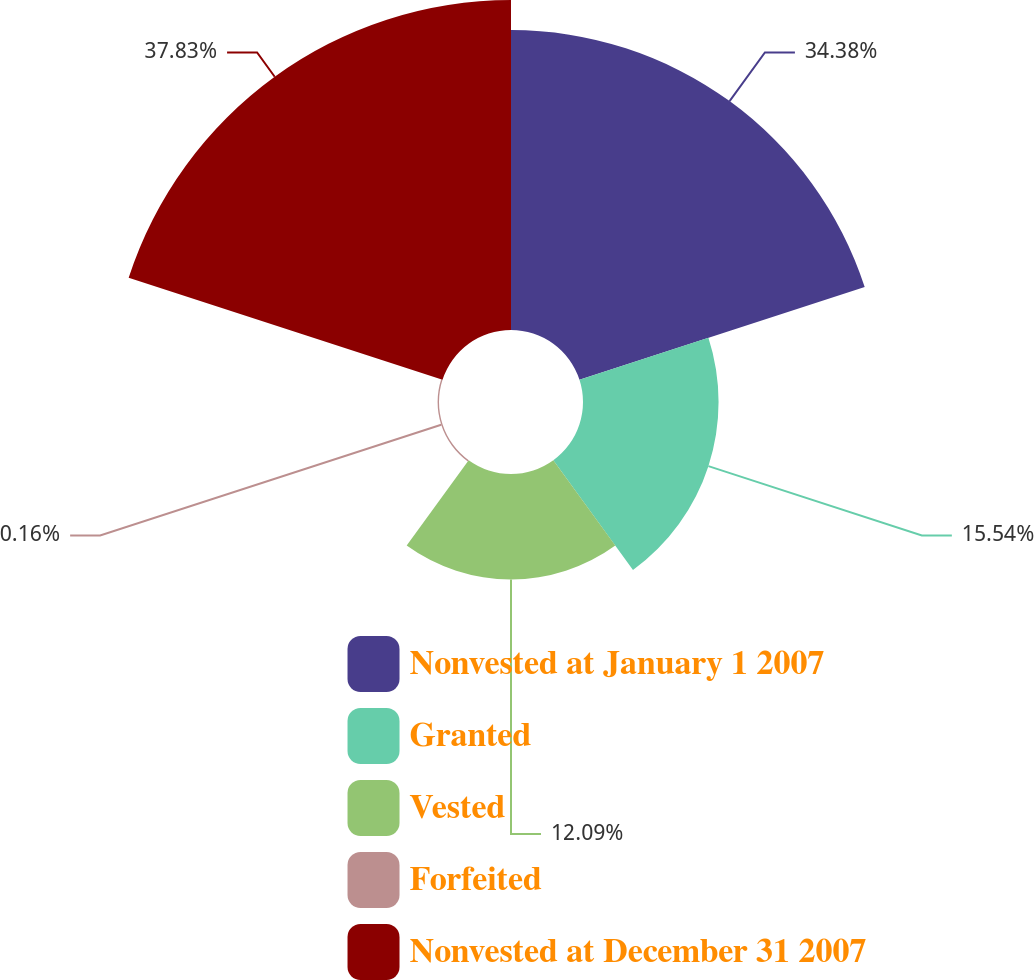Convert chart. <chart><loc_0><loc_0><loc_500><loc_500><pie_chart><fcel>Nonvested at January 1 2007<fcel>Granted<fcel>Vested<fcel>Forfeited<fcel>Nonvested at December 31 2007<nl><fcel>34.38%<fcel>15.54%<fcel>12.09%<fcel>0.16%<fcel>37.83%<nl></chart> 